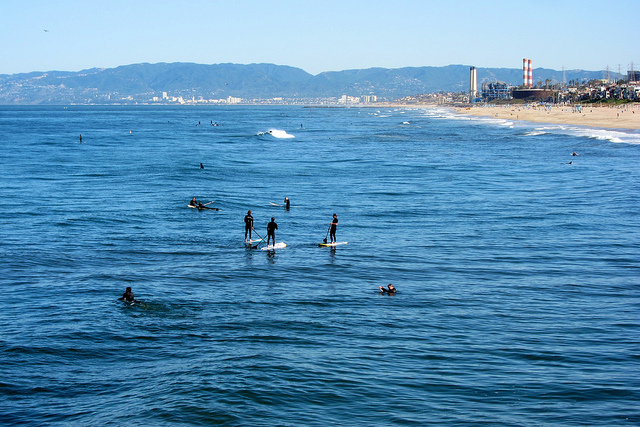<image>What type of bird is flying over water? I am not sure what type of bird is flying over water. It is either a seagull, pigeon, pelican or goose. What type of bird is flying over water? I don't know what type of bird is flying over water. It can be seagull, pigeon, pelican, or none of them. 